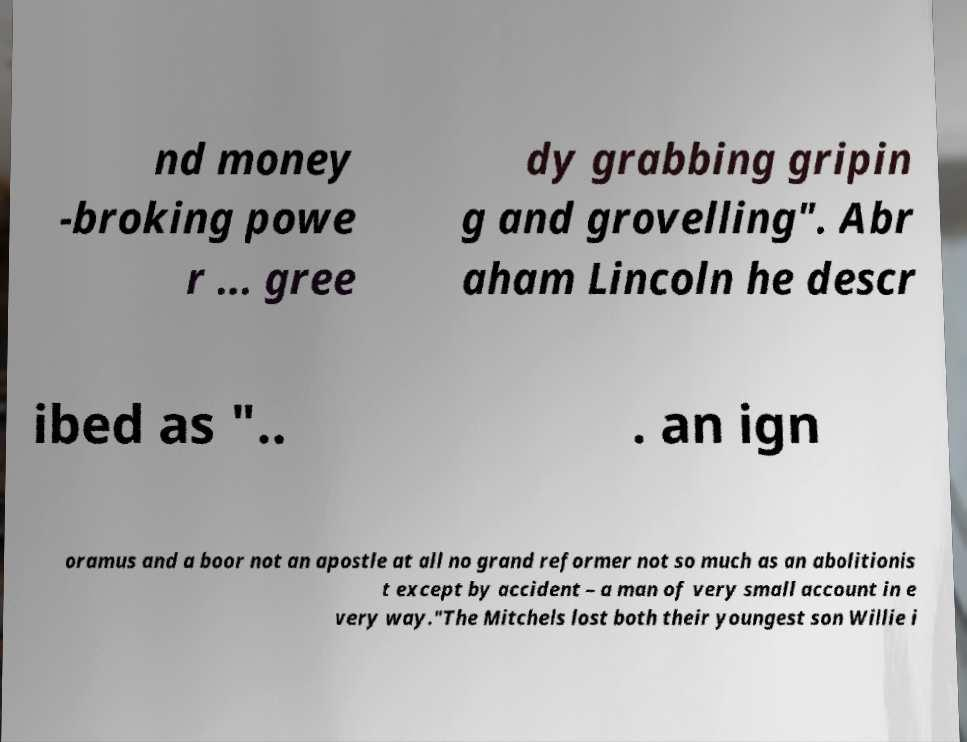Can you accurately transcribe the text from the provided image for me? nd money -broking powe r ... gree dy grabbing gripin g and grovelling". Abr aham Lincoln he descr ibed as ".. . an ign oramus and a boor not an apostle at all no grand reformer not so much as an abolitionis t except by accident – a man of very small account in e very way."The Mitchels lost both their youngest son Willie i 